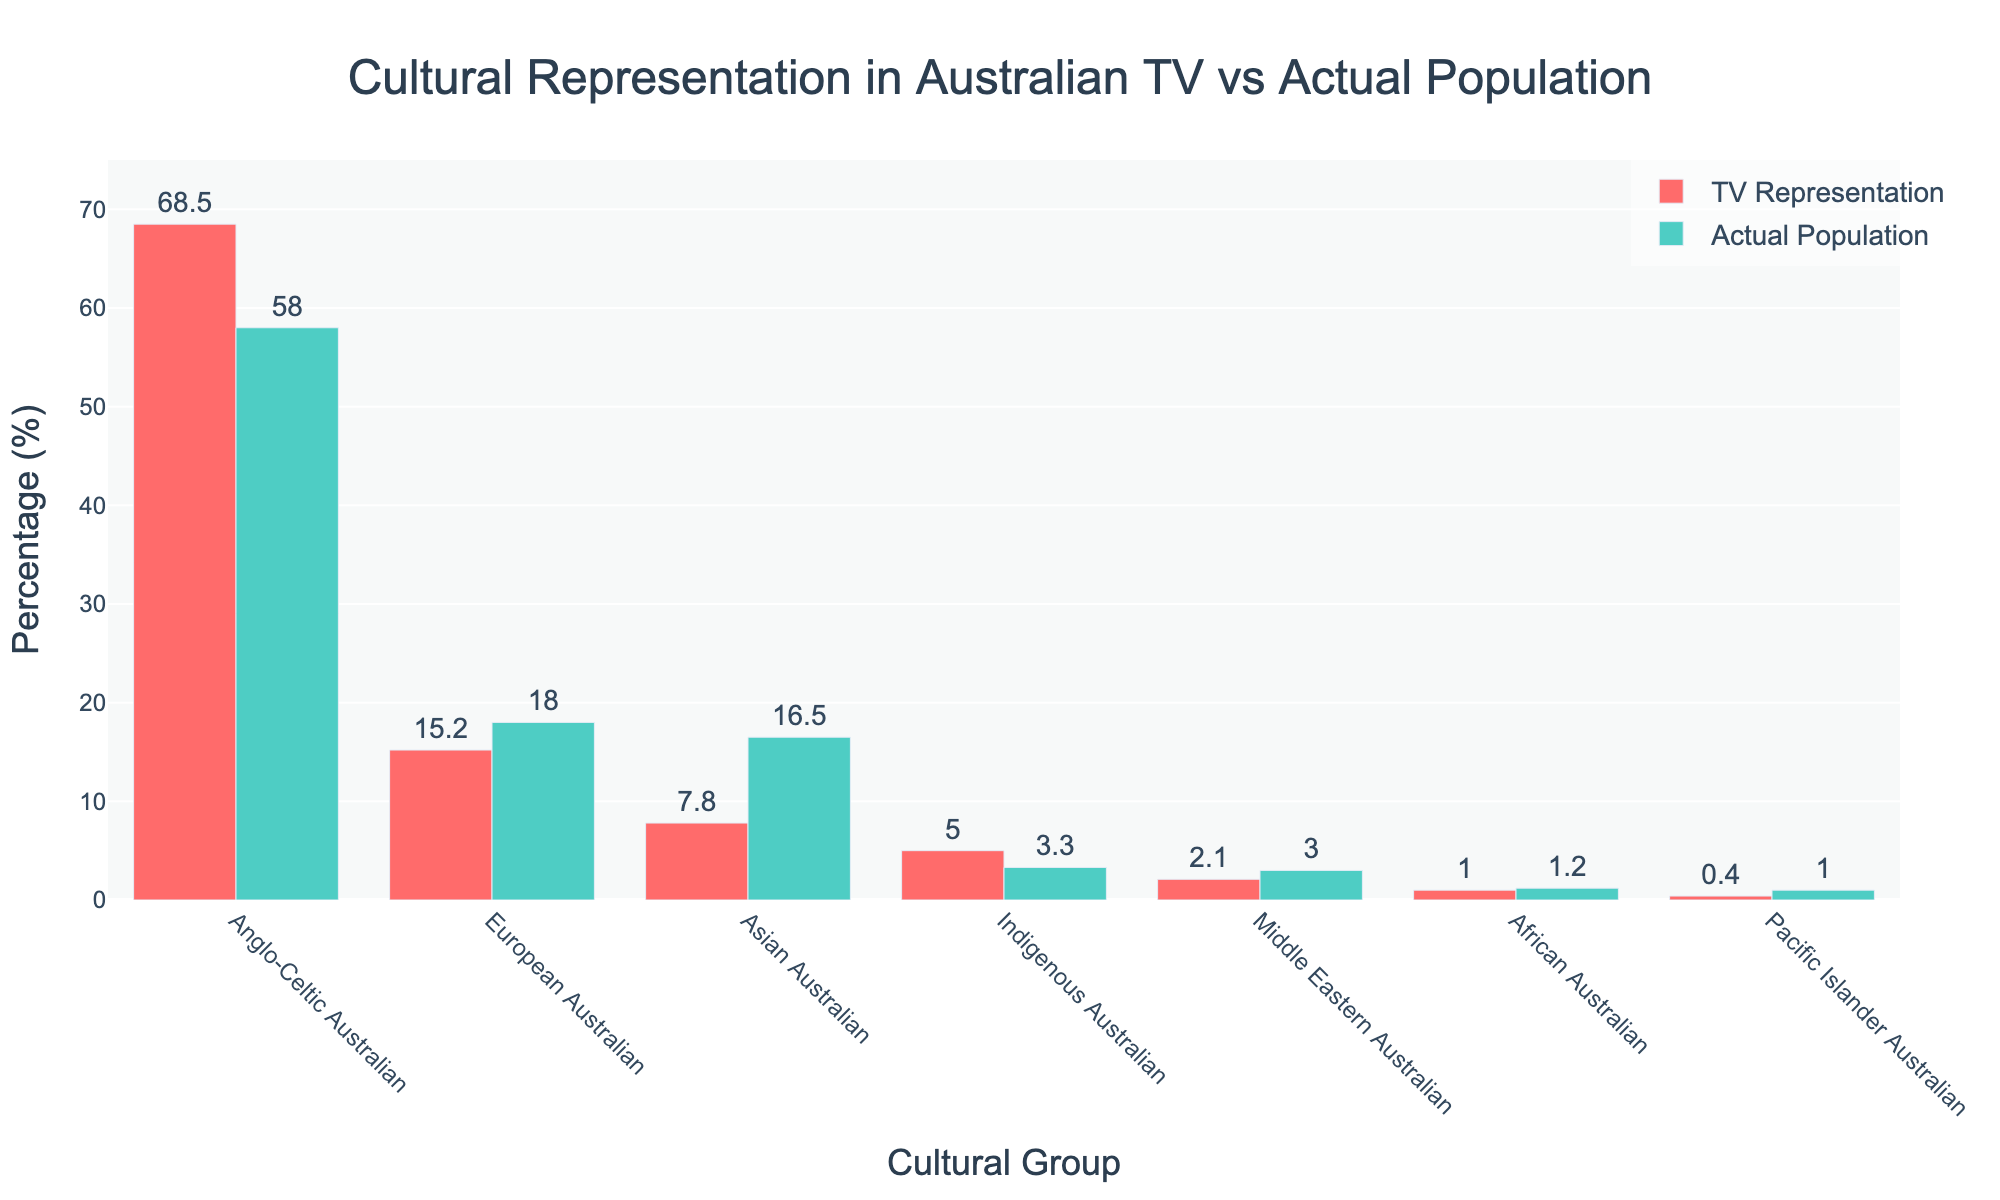Which cultural group is most overrepresented in TV shows compared to the actual population? The Anglo-Celtic Australian group has 68.5% representation in TV shows but only 58% in the actual population. The difference is 68.5% - 58% = 10.5%, the largest among the groups.
Answer: Anglo-Celtic Australian Which cultural group is most underrepresented in TV shows compared to the actual population? The Asian Australian group has 7.8% representation in TV shows but makes up 16.5% of the actual population. The difference is 16.5% - 7.8% = 8.7%, the largest deficit.
Answer: Asian Australian What is the total percentage of non-Anglo-Celtic Australian representation in TV shows? Summing up the representation of European Australian (15.2%), Asian Australian (7.8%), Indigenous Australian (5.0%), Middle Eastern Australian (2.1%), African Australian (1.0%), and Pacific Islander Australian (0.4%): 15.2% + 7.8% + 5.0% + 2.1% + 1.0% + 0.4% = 31.5%.
Answer: 31.5% Which groups are represented more in TV shows than their actual population percentage? Comparing both TV representation and actual population percentages, Anglo-Celtic Australian (68.5% vs. 58%) and Indigenous Australian (5% vs. 3.3%) are represented more in TV shows.
Answer: Anglo-Celtic Australian, Indigenous Australian Which group shows the closest match between TV representation and actual population percentage? The European Australian group has 15.2% representation in TV shows and 18% in the actual population. The difference is 18% - 15.2% = 2.8%, which is the smallest among the groups.
Answer: European Australian Which two groups combined have a higher percentage in TV representation than Anglo-Celtic Australians? The combined TV representation of the European Australian (15.2%) and Asian Australian (7.8%) groups is 15.2% + 7.8% = 23%. Comparing with Anglo-Celtic Australian's 68.5%, 23% is much lower. Trying another combination, Indigenous Australian (5.0%) and Asian Australian (7.8%) gives 5.0% + 7.8% = 12.8%. However, none of the combinations exceed 68.5%.
Answer: None By how much does the Indigenous Australian representation in TV shows exceed their actual population percentage? Indigenous Australians have a 5.0% representation in TV shows compared to 3.3% in the actual population. The excess representation is 5.0% - 3.3% = 1.7%.
Answer: 1.7% Which three groups have the smallest difference (either overrepresented or underrepresented) between TV representation and actual population? European Australian (2.8% underrepresented), Indigenous Australian (1.7% overrepresented), and Middle Eastern Australian (0.9% underrepresented). These groups have the smallest differences.
Answer: European Australian, Indigenous Australian, Middle Eastern Australian 